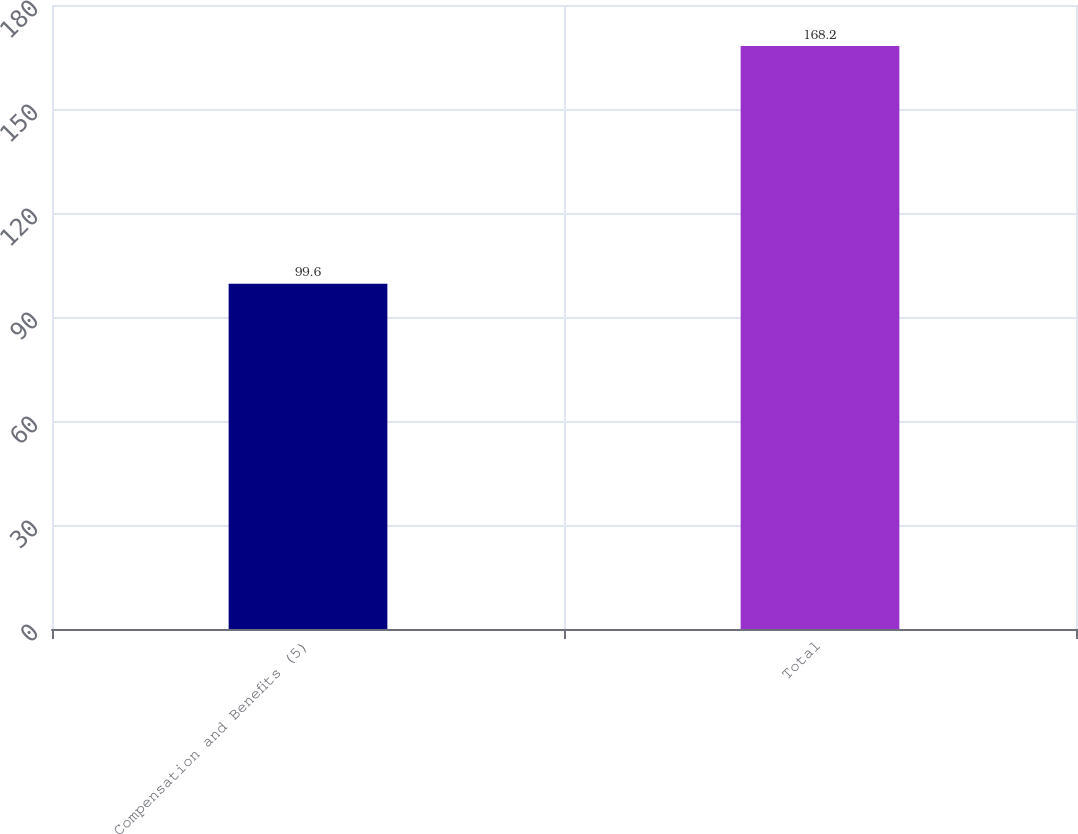Convert chart. <chart><loc_0><loc_0><loc_500><loc_500><bar_chart><fcel>Compensation and Benefits (5)<fcel>Total<nl><fcel>99.6<fcel>168.2<nl></chart> 